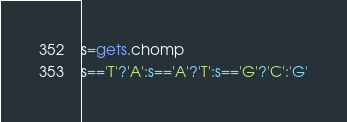Convert code to text. <code><loc_0><loc_0><loc_500><loc_500><_Ruby_>s=gets.chomp
s=='T'?'A':s=='A'?'T':s=='G'?'C':'G'</code> 